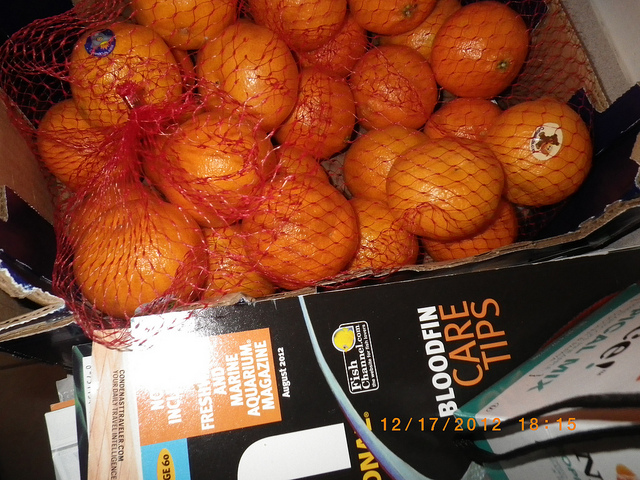Identify the text contained in this image. BLOODFIN CARS TIPS 12/17/2012 18:15 12/17/2012 CONOLNASTTRAVELER.COM GE FRESH AND MARINE AQUARIUM MAGAINE 2012 August Fish Channel.com MIX Fish 